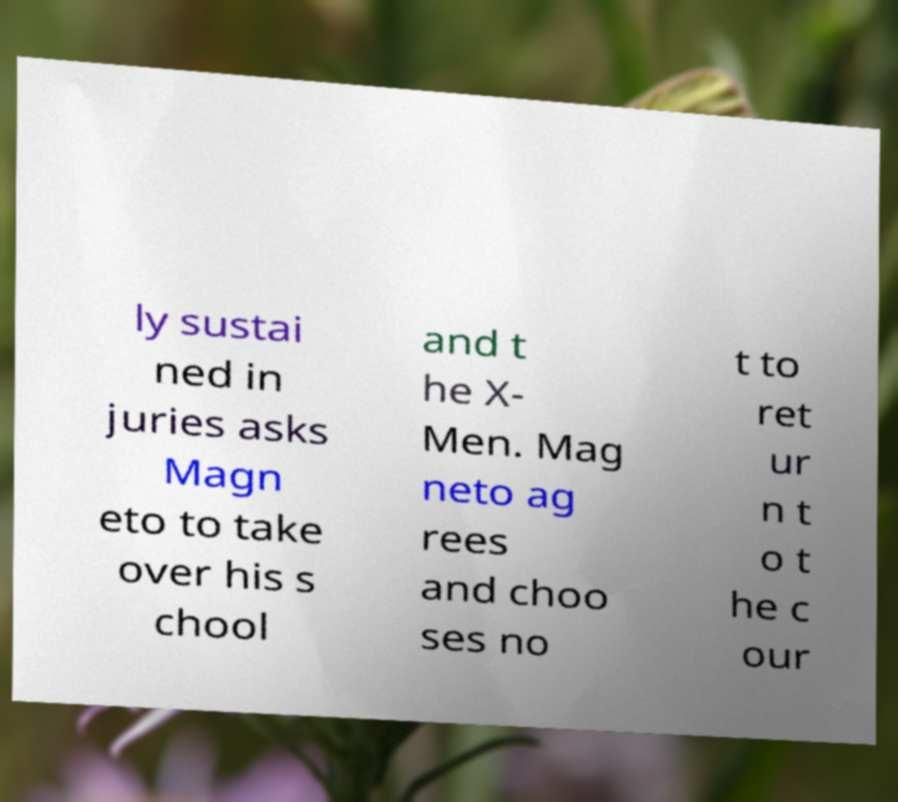There's text embedded in this image that I need extracted. Can you transcribe it verbatim? ly sustai ned in juries asks Magn eto to take over his s chool and t he X- Men. Mag neto ag rees and choo ses no t to ret ur n t o t he c our 